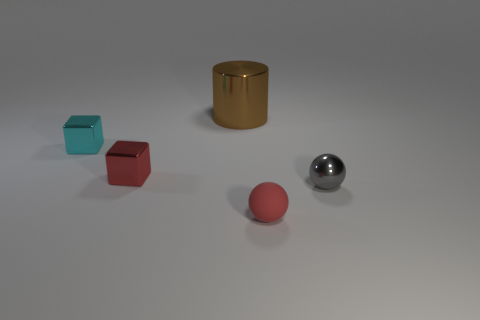Is there any other thing that has the same size as the brown cylinder?
Keep it short and to the point. No. Is there anything else that is made of the same material as the red ball?
Provide a short and direct response. No. Is there a tiny green cylinder made of the same material as the tiny red ball?
Offer a terse response. No. There is a thing that is behind the red metallic object and in front of the metallic cylinder; what color is it?
Offer a very short reply. Cyan. How many other objects are there of the same color as the rubber object?
Ensure brevity in your answer.  1. The red thing that is left of the red object that is in front of the tiny shiny object on the right side of the big brown metallic thing is made of what material?
Give a very brief answer. Metal. What number of balls are either small rubber objects or gray metallic objects?
Make the answer very short. 2. There is a red object that is in front of the tiny shiny object that is right of the tiny matte ball; what number of cyan cubes are in front of it?
Keep it short and to the point. 0. Is the shape of the big metal object the same as the small cyan shiny thing?
Your response must be concise. No. Is the tiny red thing behind the small red rubber object made of the same material as the small thing to the right of the tiny rubber thing?
Provide a succinct answer. Yes. 